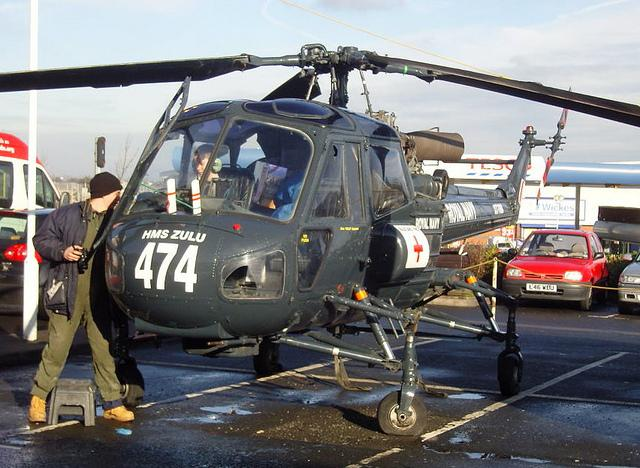What kind of chopper is this? Please explain your reasoning. medical. There is a red cross on it which is an international sign for medical 